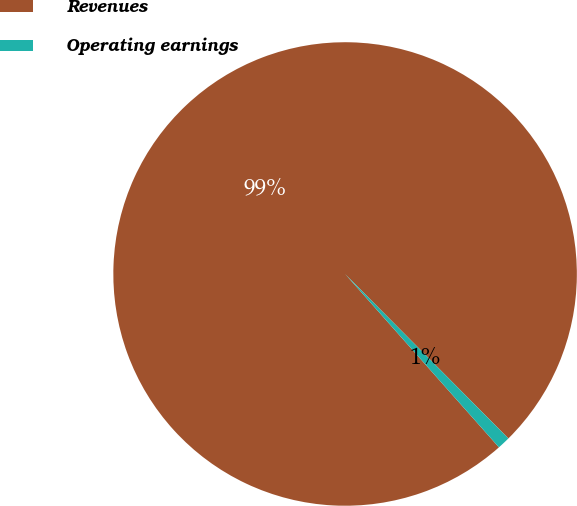<chart> <loc_0><loc_0><loc_500><loc_500><pie_chart><fcel>Revenues<fcel>Operating earnings<nl><fcel>99.11%<fcel>0.89%<nl></chart> 